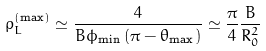Convert formula to latex. <formula><loc_0><loc_0><loc_500><loc_500>\rho _ { L } ^ { \left ( \max \right ) } \simeq \frac { 4 } { B \phi _ { \min } \left ( \pi - \theta _ { \max } \right ) } \simeq \frac { \pi } { 4 } \frac { B } { R _ { 0 } ^ { 2 } }</formula> 